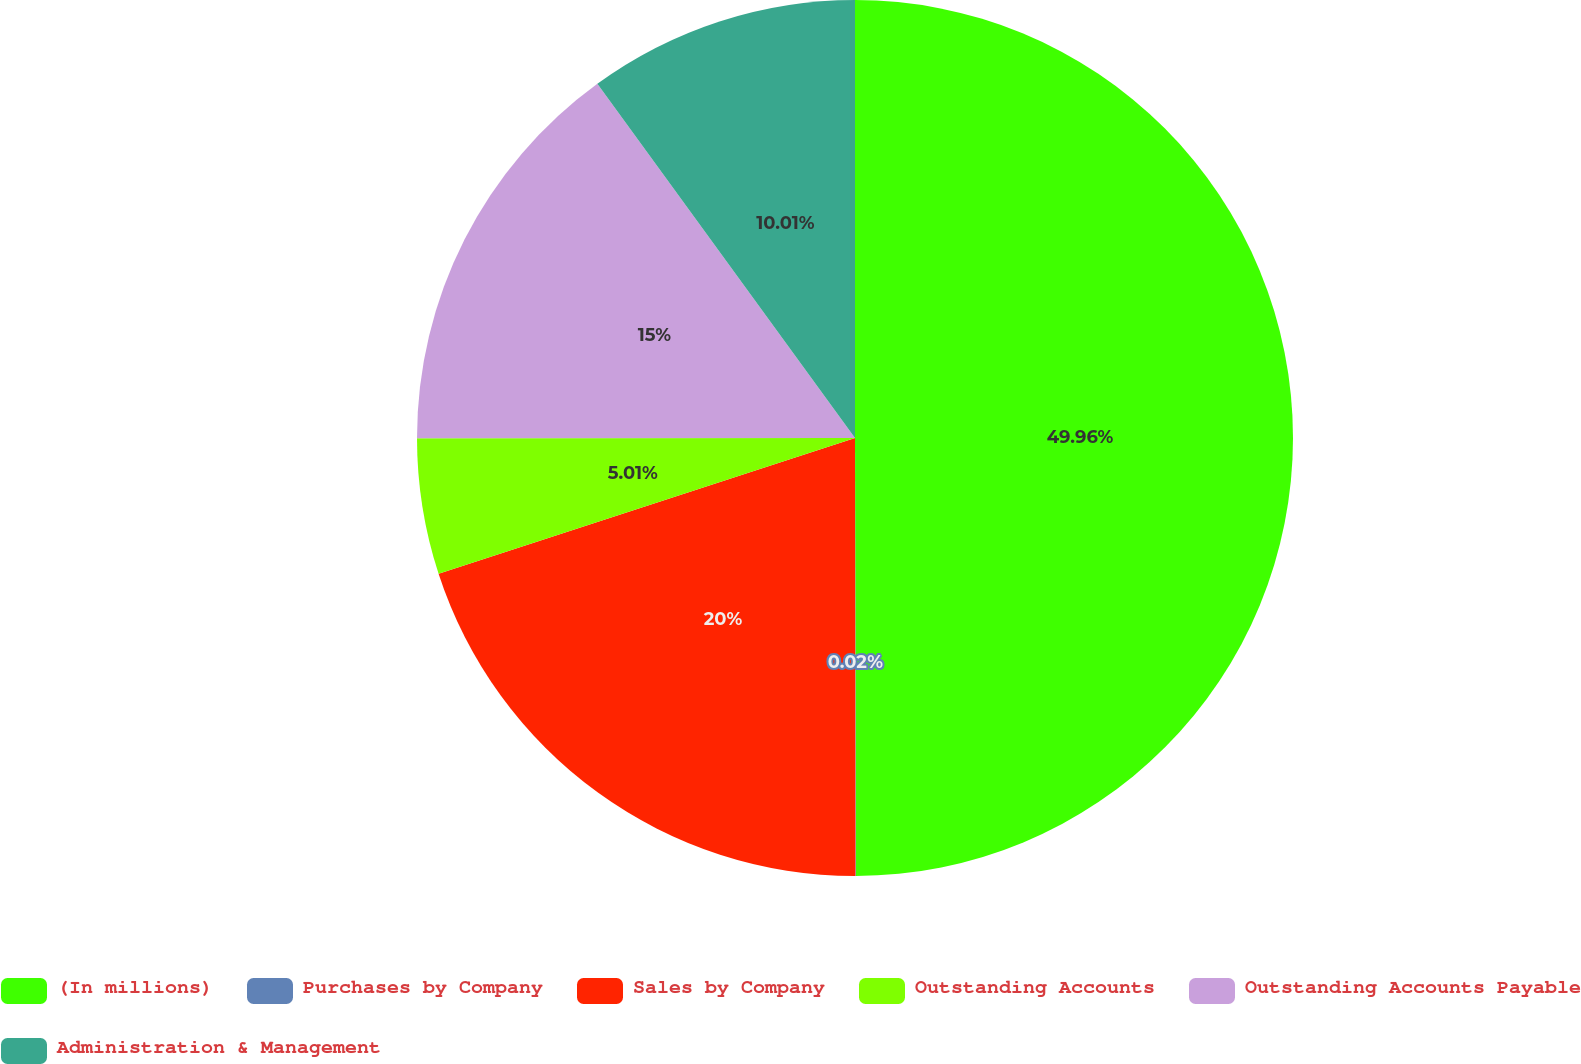Convert chart to OTSL. <chart><loc_0><loc_0><loc_500><loc_500><pie_chart><fcel>(In millions)<fcel>Purchases by Company<fcel>Sales by Company<fcel>Outstanding Accounts<fcel>Outstanding Accounts Payable<fcel>Administration & Management<nl><fcel>49.97%<fcel>0.02%<fcel>20.0%<fcel>5.01%<fcel>15.0%<fcel>10.01%<nl></chart> 